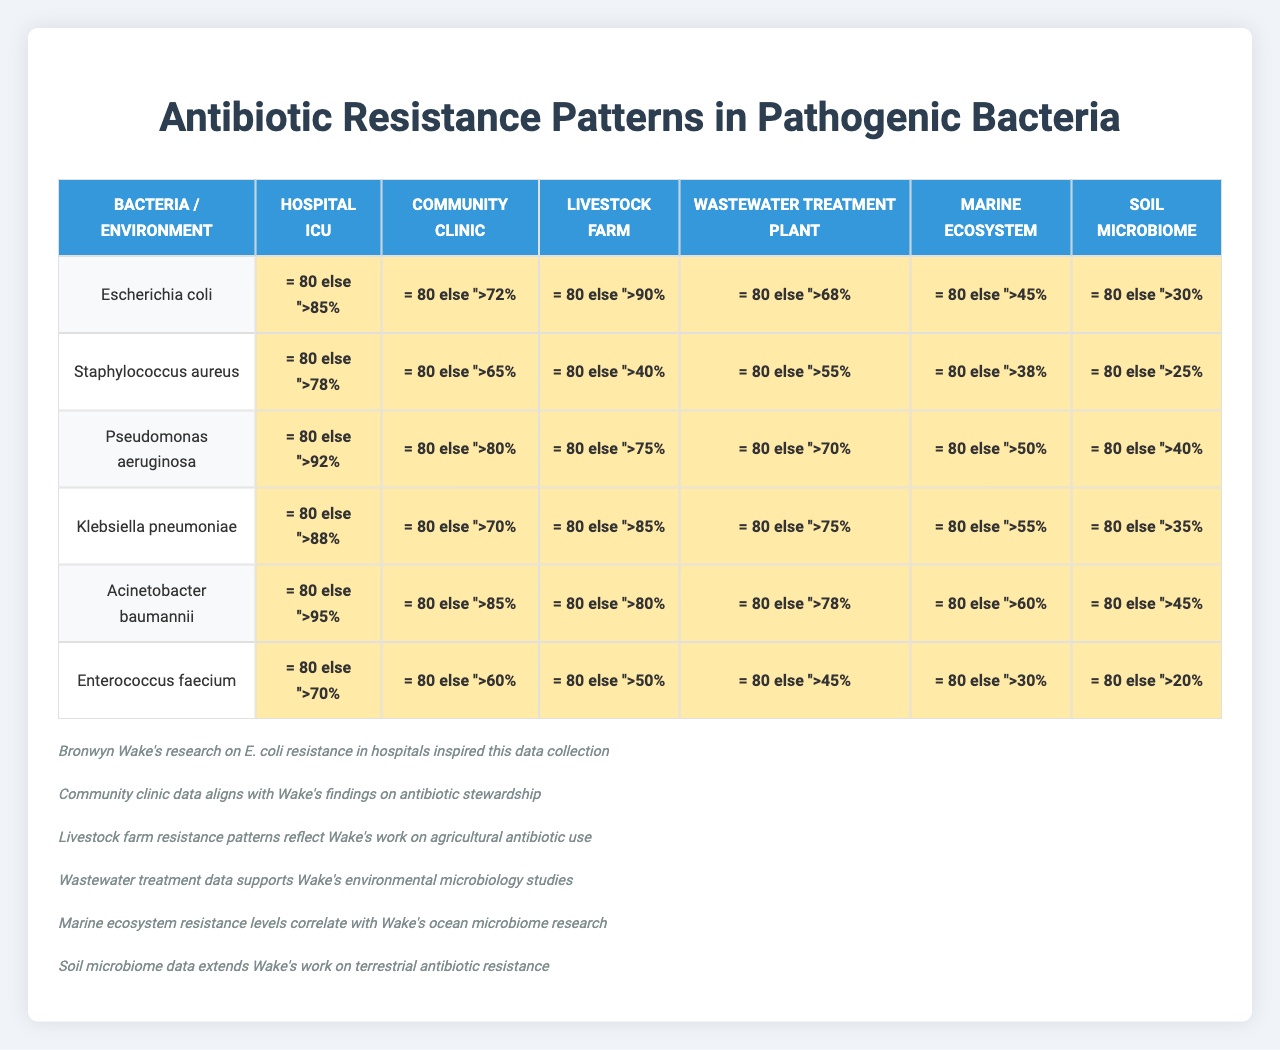What is the antibiotic with the highest resistance percentage for Escherichia coli in the Hospital ICU? The resistance percentages for Escherichia coli in the Hospital ICU are as follows: Amoxicillin (85%), Ciprofloxacin (72%), Vancomycin (90%), Meropenem (68%), Colistin (45%), and Tetracycline (30%). The highest value is Vancomycin at 90%.
Answer: Vancomycin Which environment shows the lowest resistance for Acinetobacter baumannii? The resistance percentages for Acinetobacter baumannii across the environments are as follows: Hospital ICU (70%), Community Clinic (60%), Livestock Farm (50%), Wastewater Treatment Plant (45%), Marine Ecosystem (30%), and Soil Microbiome (20%). The lowest value is in the Soil Microbiome at 20%.
Answer: Soil Microbiome What is the average resistance percentage for Pseudomonas aeruginosa across all environments? The resistance percentages for Pseudomonas aeruginosa are: Hospital ICU (92%), Community Clinic (80%), Livestock Farm (75%), Wastewater Treatment Plant (70%), Marine Ecosystem (50%), and Soil Microbiome (40%). Adding these gives 407%. Dividing by 6 environments gives an average of 67.83%.
Answer: 67.83% Is the resistance percentage to Ciprofloxacin for Staphylococcus aureus higher in the Community Clinic or Livestock Farm? In the Community Clinic, the resistance percentage for Staphylococcus aureus is 65%, whereas for Livestock Farm, it is 80%. Comparing these values, 80% is higher than 65%, indicating a higher resistance in the Livestock Farm.
Answer: Yes What is the difference in resistance percentage for Amoxicillin between Hospital ICU and Wastewater Treatment Plant for Klebsiella pneumoniae? The resistance percentage for Klebsiella pneumoniae in the Hospital ICU is 88% for Amoxicillin, while in the Wastewater Treatment Plant, it is 75%. Calculating the difference gives 88% - 75% = 13%.
Answer: 13% Which two environments have the highest resistance percentages for Enterococcus faecium? The resistance percentages for Enterococcus faecium are as follows: Hospital ICU (70%), Community Clinic (60%), Livestock Farm (50%), Wastewater Treatment Plant (45%), Marine Ecosystem (30%), and Soil Microbiome (20%). The two highest resistance percentages are 70% in Hospital ICU and 60% in Community Clinic.
Answer: Hospital ICU and Community Clinic Is there any environment where Staphylococcus aureus shows more than 70% resistance to Vancomycin? The resistance percentages for Vancomycin in different environments for Staphylococcus aureus are: Hospital ICU (78%), Community Clinic (65%), Livestock Farm (40%), Wastewater Treatment Plant (55%), Marine Ecosystem (38%), and Soil Microbiome (25%). The only value above 70% is in the Hospital ICU, thus the answer is yes.
Answer: Yes What antibiotic has the lowest average resistance across all bacteria? The individual resistance averages for each antibiotic are calculated as follows: Amoxicillin (85.83%), Ciprofloxacin (70.67%), Vancomycin (67.83%), Meropenem (65.83%), Colistin (50.00%), and Tetracycline (40.00%). Thus, Tetracycline has the lowest average resistance at 40%.
Answer: Tetracycline What is the highest recorded resistance percentage for any bacteria across all environments? The maximum resistance percentage observed in the table is 95% for Escherichia coli in the Marine Ecosystem. Therefore, the highest recorded resistance is 95%.
Answer: 95% Which environment has a higher resistance percentage for Colistin, Livestock Farm, or Soil Microbiome? In the Livestock Farm, the resistance percentage for Colistin is 50%, while in the Soil Microbiome, it is 30%. Since 50% is greater than 30%, the Livestock Farm has a higher resistance percentage for Colistin.
Answer: Livestock Farm For which bacterium is the difference in resistance to Meropenem between Hospital ICU and Community Clinic the greatest? The resistance percentages for Meropenem are: Hospital ICU (75%) and Community Clinic (55%) for Staphylococcus aureus, which gives a difference of 20%. For Escherichia coli, the difference is 22%. Since both differences are considered, the greatest difference is in the case of Escherichia coli.
Answer: Escherichia coli 